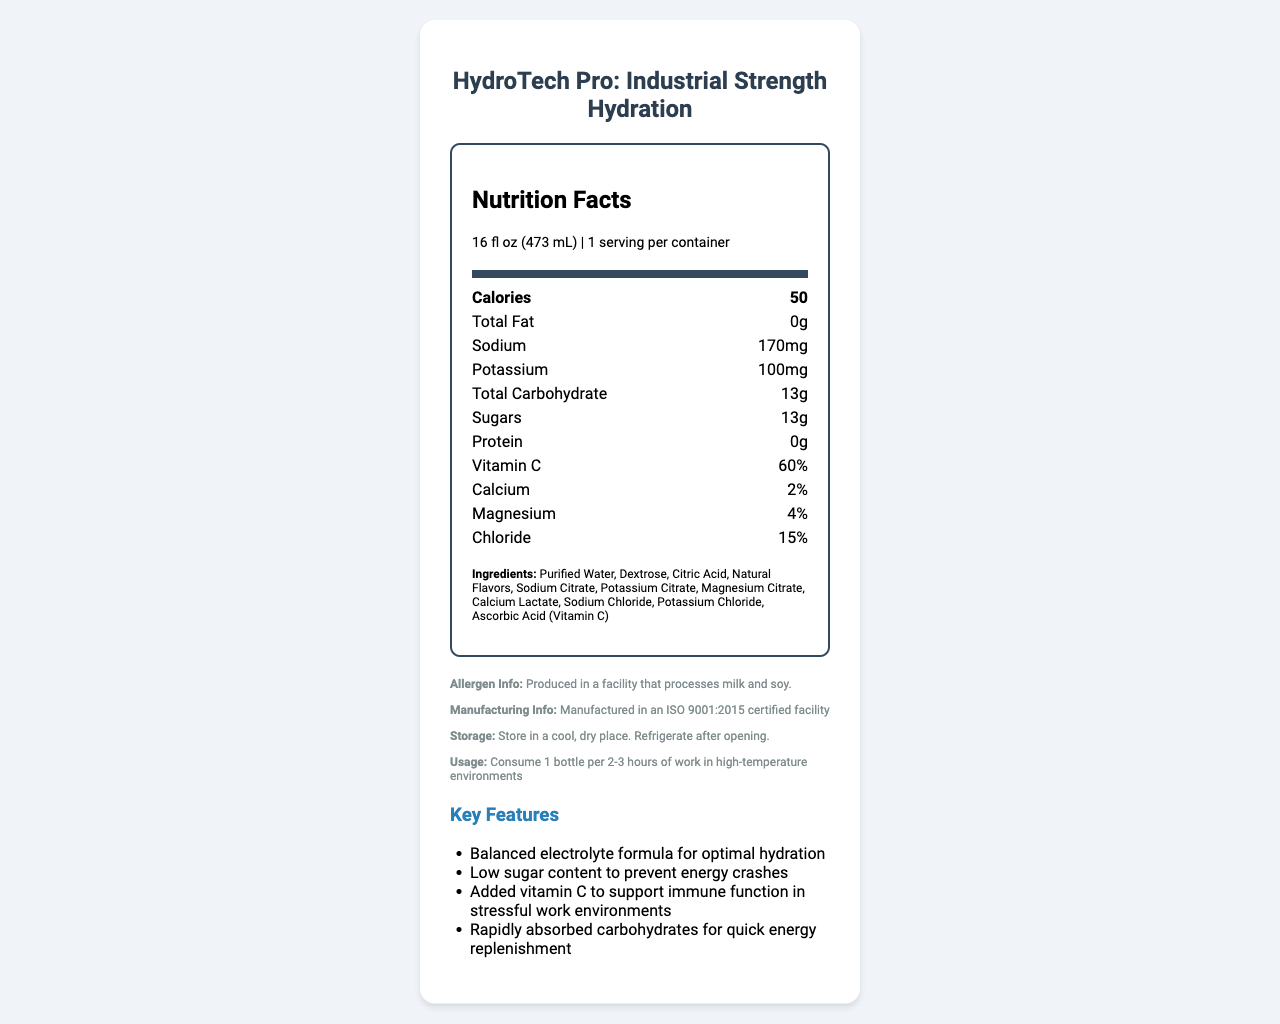what is the serving size of HydroTech Pro? The serving size is listed at the top of the Nutrition Facts section as 16 fl oz (473 mL).
Answer: 16 fl oz (473 mL) how many calories are in one serving of HydroTech Pro? The number of calories per serving is specified in the bold section of the Nutrition Facts as 50.
Answer: 50 calories what is the sodium content per serving? Sodium content per serving is listed under the nutritional information as 170mg.
Answer: 170mg which ingredient provides Vitamin C in HydroTech Pro? The ingredient list includes ascorbic acid, which is known to provide Vitamin C.
Answer: Ascorbic Acid how many grams of sugars are in a single serving? The sugars content per serving is listed as 13g.
Answer: 13g what is the recommended consumption interval for HydroTech Pro in high-temperature environments? The usage instructions state to consume 1 bottle per 2-3 hours of work in high-temperature environments.
Answer: 1 bottle per 2-3 hours which of the following is NOT a key feature of HydroTech Pro? A. High protein content B. Balanced electrolyte formula C. Low sugar content The key features listed include a balanced electrolyte formula and low sugar content, but do not mention high protein content.
Answer: A how long is the shelf life of HydroTech Pro from the date of manufacture? A. 6 months B. 12 months C. 18 months D. 24 months The document specifies that the shelf life is 18 months from the date of manufacture.
Answer: C is HydroTech Pro produced in an allergen-free facility? The allergen info section states it is produced in a facility that processes milk and soy.
Answer: No does HydroTech Pro contain any fat? The total fat content is specified as 0g.
Answer: No who is the intended audience for HydroTech Pro? The target audience is mentioned as manufacturing workers in high-temperature environments.
Answer: Manufacturing workers in high-temperature environments is HydroTech Pro packaging environmentally friendly? The packaging is described as BPA-free and recyclable PET bottle, indicating it is environmentally friendly.
Answer: Yes describe the main idea of the document. The document includes a nutrition facts table, a list of ingredients, usage instructions, key features such as balanced electrolyte formula and low sugar content, allergen information, and storage instructions.
Answer: The document provides detailed nutritional information and key features of the HydroTech Pro electrolyte drink, emphasizing its benefits for hydration and energy replenishment in high-temperature manufacturing environments. how much protein does HydroTech Pro contain per serving? The protein content is listed in the nutritional information as 0g per serving.
Answer: 0g what certification does HydroTech Pro have? The certification mentioned at the end of the document is NSF Certified for Sport®.
Answer: NSF Certified for Sport® what is the chloride content per serving of HydroTech Pro? The chloride content per serving is listed as 15%.
Answer: 15% does the document provide information about the environmental impact of the manufacturing process? The document does not provide details about the environmental impact of the manufacturing process itself, only information about the packaging.
Answer: Not enough information 